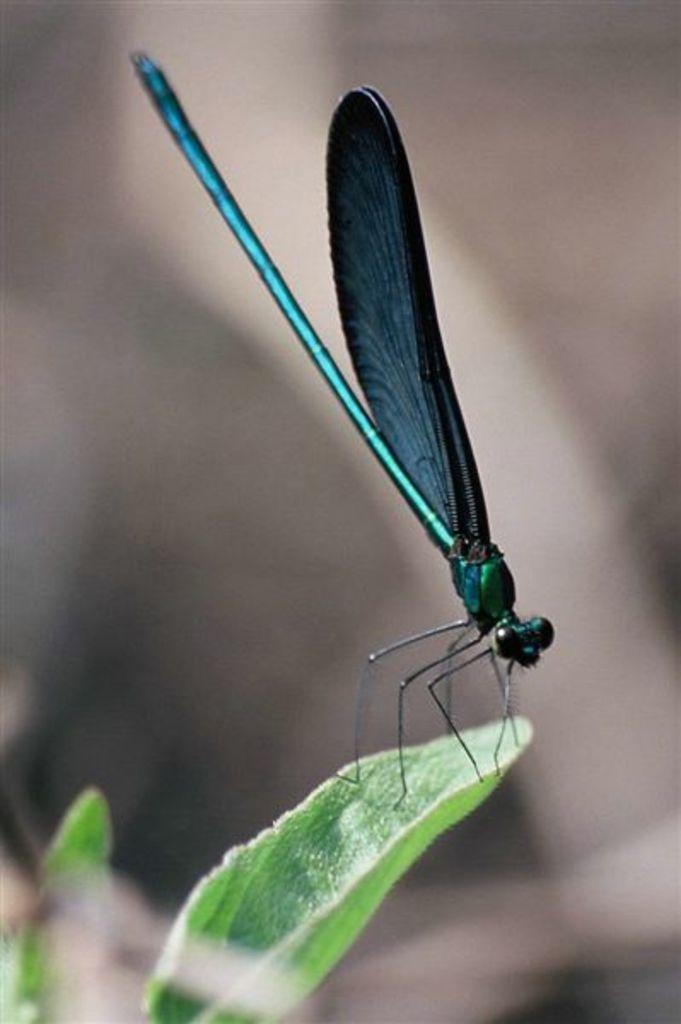What is the main subject of the image? There is an insect on a leaf in the image. What type of vegetation is present in the image? There are leaves in the image. Can you describe the background of the image? The background of the image is blurred. What type of stitch is used to sew the insect's wings together in the image? There is no stitch or sewing present in the image; it features an insect on a leaf. Can you describe the insect's attack on the leaf in the image? There is no attack or aggressive behavior depicted in the image; the insect is simply resting on the leaf. 